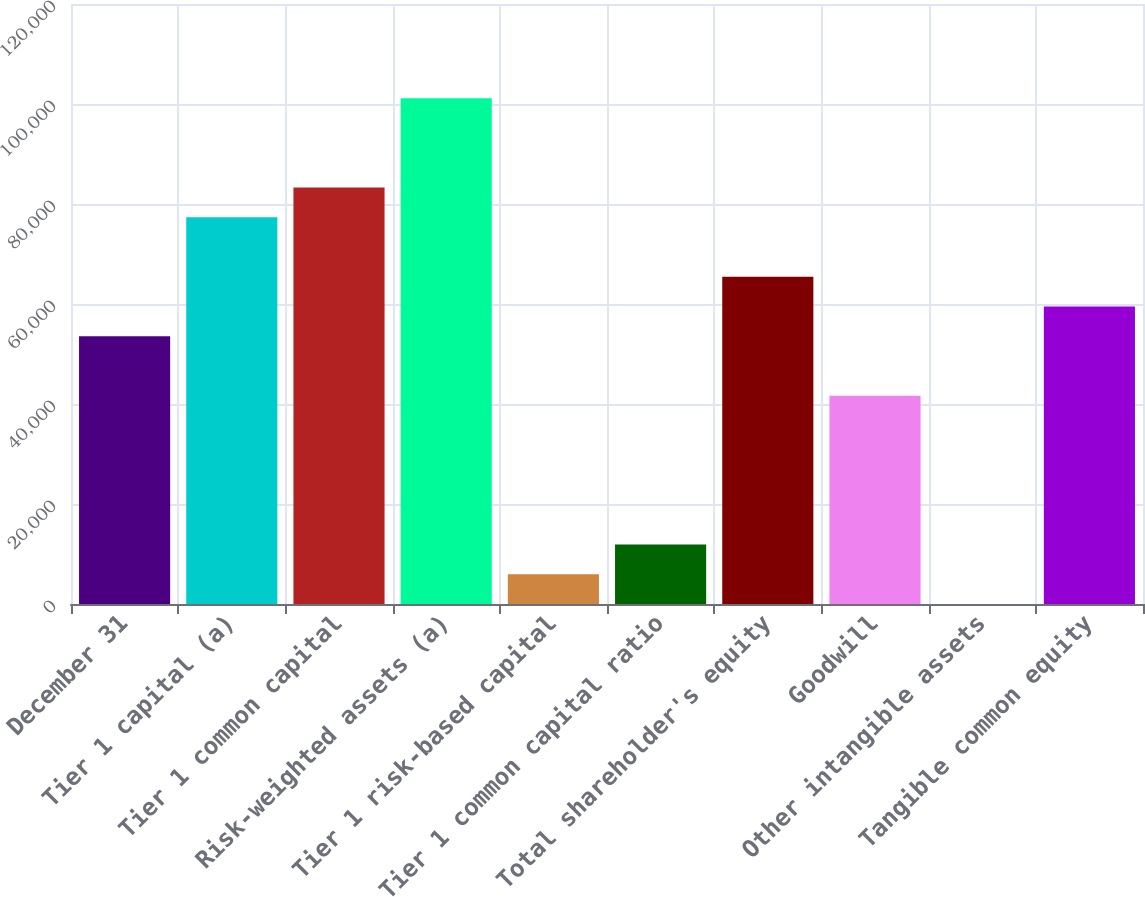<chart> <loc_0><loc_0><loc_500><loc_500><bar_chart><fcel>December 31<fcel>Tier 1 capital (a)<fcel>Tier 1 common capital<fcel>Risk-weighted assets (a)<fcel>Tier 1 risk-based capital<fcel>Tier 1 common capital ratio<fcel>Total shareholder's equity<fcel>Goodwill<fcel>Other intangible assets<fcel>Tangible common equity<nl><fcel>53556<fcel>77356<fcel>83306<fcel>101156<fcel>5956<fcel>11906<fcel>65456<fcel>41656<fcel>6<fcel>59506<nl></chart> 